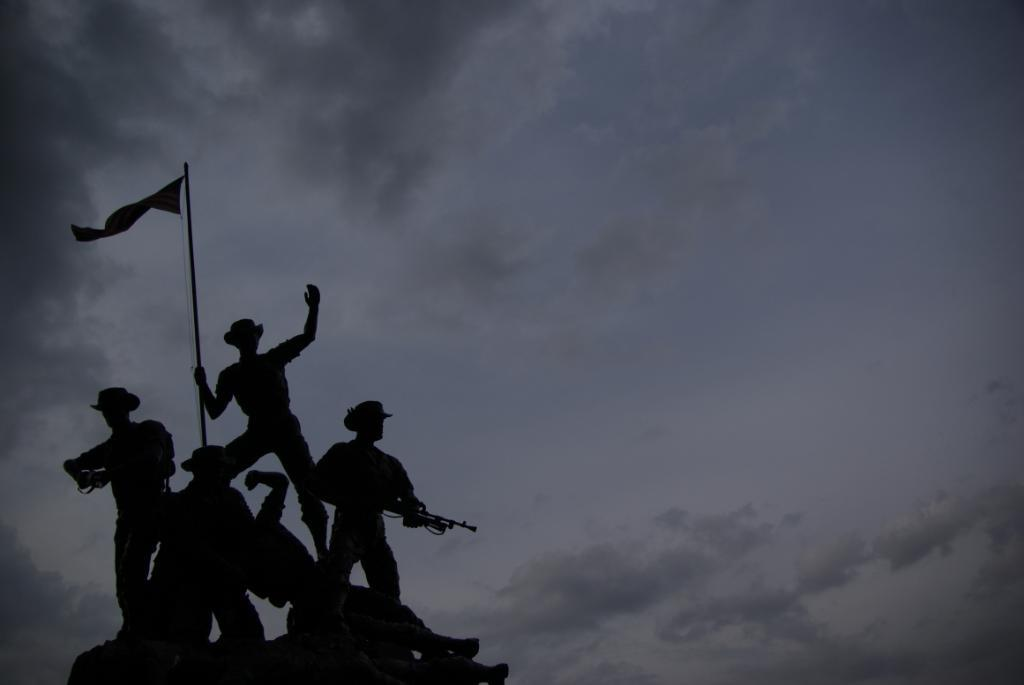What is the main subject of the image? There is a sculpture in the image. What does the sculpture depict? The sculpture depicts soldiers. What are the soldiers holding in the sculpture? The soldiers are holding weapons. Is there any other element present in the sculpture? Yes, there is a flag in the sculpture. How many ants can be seen crawling on the soldiers in the image? There are no ants present in the image; it features a sculpture of soldiers holding weapons and a flag. What type of needle is being used by the mom in the image? There is no mom or needle present in the image; it only features a sculpture of soldiers. 